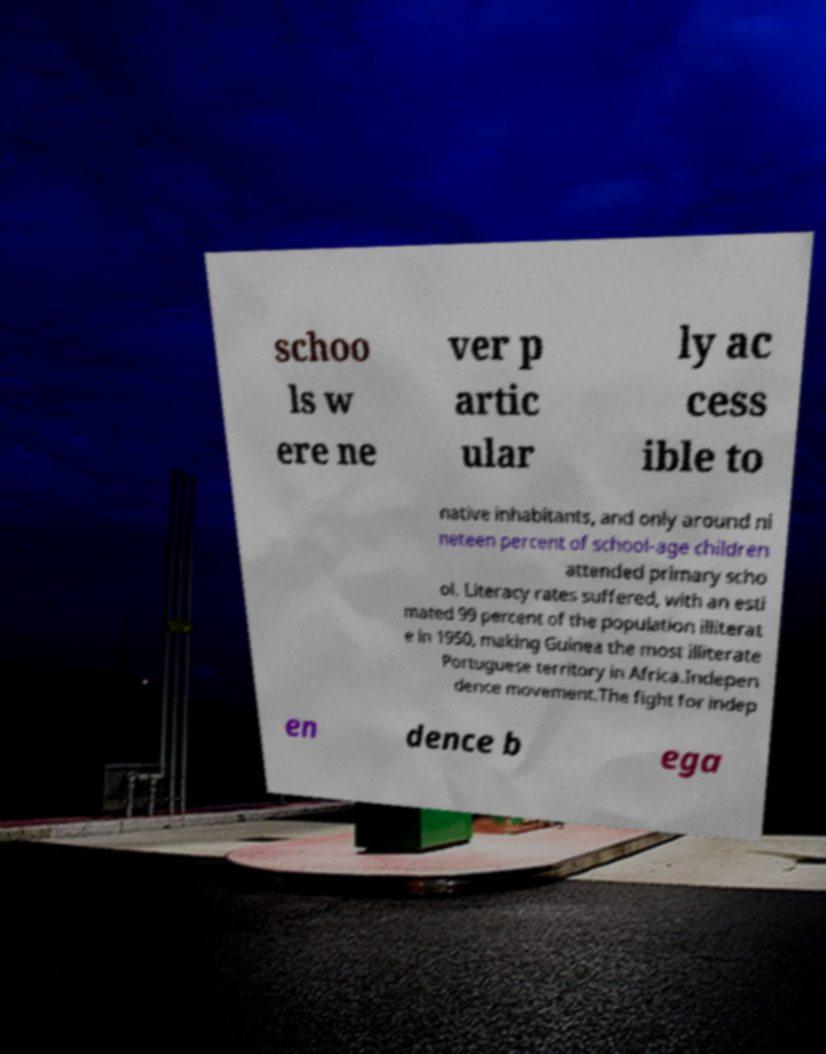I need the written content from this picture converted into text. Can you do that? schoo ls w ere ne ver p artic ular ly ac cess ible to native inhabitants, and only around ni neteen percent of school-age children attended primary scho ol. Literacy rates suffered, with an esti mated 99 percent of the population illiterat e in 1950, making Guinea the most illiterate Portuguese territory in Africa.Indepen dence movement.The fight for indep en dence b ega 